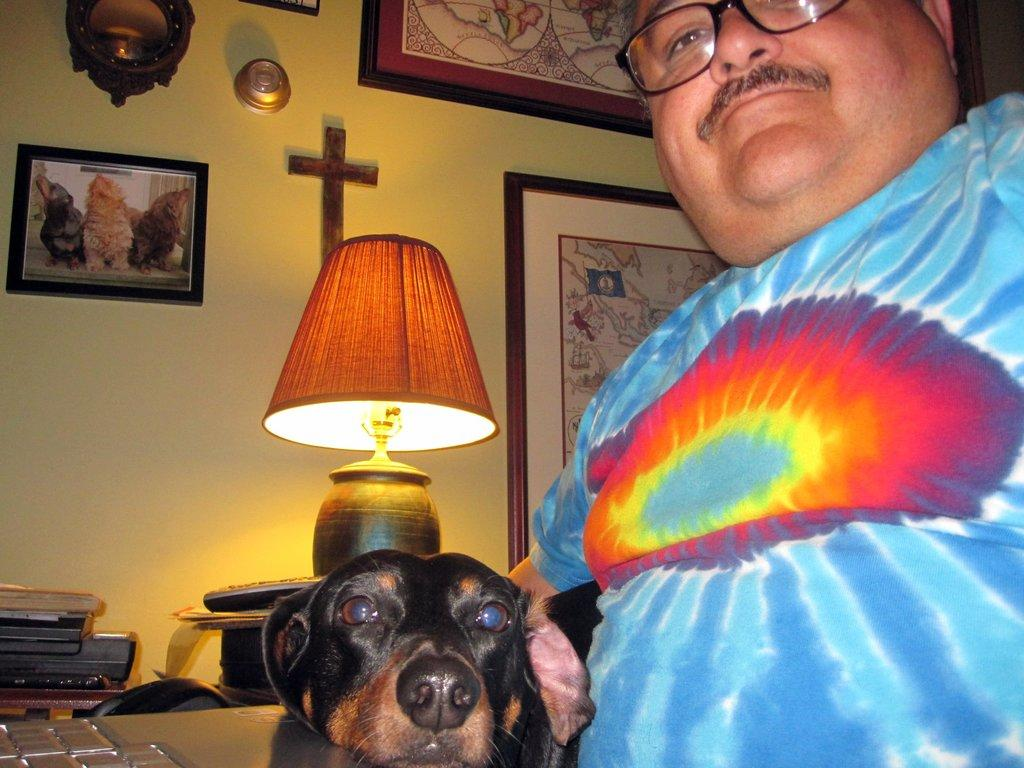What is located on the right side of the image? There is a man on the right side of the image. What is the man wearing? The man is wearing a t-shirt.shirt. What type of animal can be seen in the image? There is a dog in the image. What can be seen in the background of the image? There are photo frames, a lamplight, books, a remote, and other items in the background of the image. Can you see any ants crawling on the man's t-shirt in the image? There are no ants visible on the man's t-shirt in the image. Is there a giraffe in the image? No, there is no giraffe present in the image. 